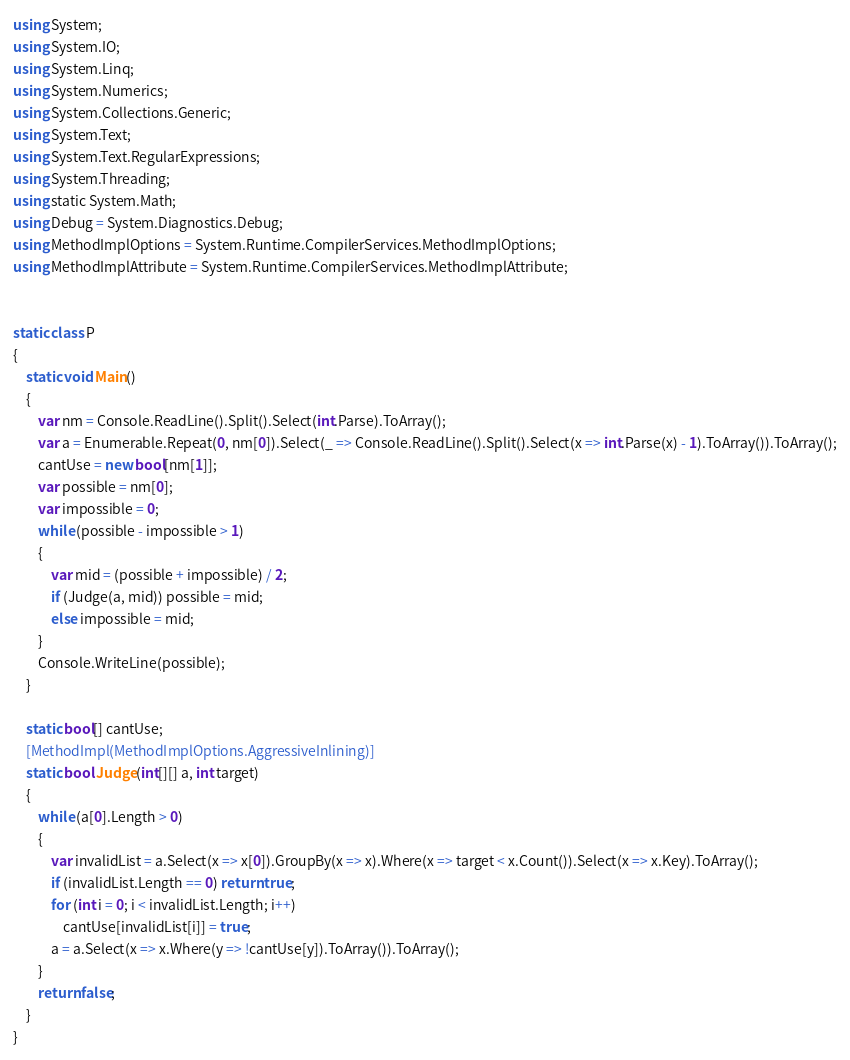<code> <loc_0><loc_0><loc_500><loc_500><_C#_>using System;
using System.IO;
using System.Linq;
using System.Numerics;
using System.Collections.Generic;
using System.Text;
using System.Text.RegularExpressions;
using System.Threading;
using static System.Math;
using Debug = System.Diagnostics.Debug;
using MethodImplOptions = System.Runtime.CompilerServices.MethodImplOptions;
using MethodImplAttribute = System.Runtime.CompilerServices.MethodImplAttribute;


static class P
{
    static void Main()
    {
        var nm = Console.ReadLine().Split().Select(int.Parse).ToArray();
        var a = Enumerable.Repeat(0, nm[0]).Select(_ => Console.ReadLine().Split().Select(x => int.Parse(x) - 1).ToArray()).ToArray();
        cantUse = new bool[nm[1]];
        var possible = nm[0];
        var impossible = 0;
        while (possible - impossible > 1)
        {
            var mid = (possible + impossible) / 2;
            if (Judge(a, mid)) possible = mid;
            else impossible = mid;
        }
        Console.WriteLine(possible);
    }

    static bool[] cantUse;
    [MethodImpl(MethodImplOptions.AggressiveInlining)]
    static bool Judge(int[][] a, int target)
    {
        while (a[0].Length > 0)
        {
            var invalidList = a.Select(x => x[0]).GroupBy(x => x).Where(x => target < x.Count()).Select(x => x.Key).ToArray();
            if (invalidList.Length == 0) return true;
            for (int i = 0; i < invalidList.Length; i++)
                cantUse[invalidList[i]] = true;
            a = a.Select(x => x.Where(y => !cantUse[y]).ToArray()).ToArray();
        }
        return false;
    }
}
</code> 